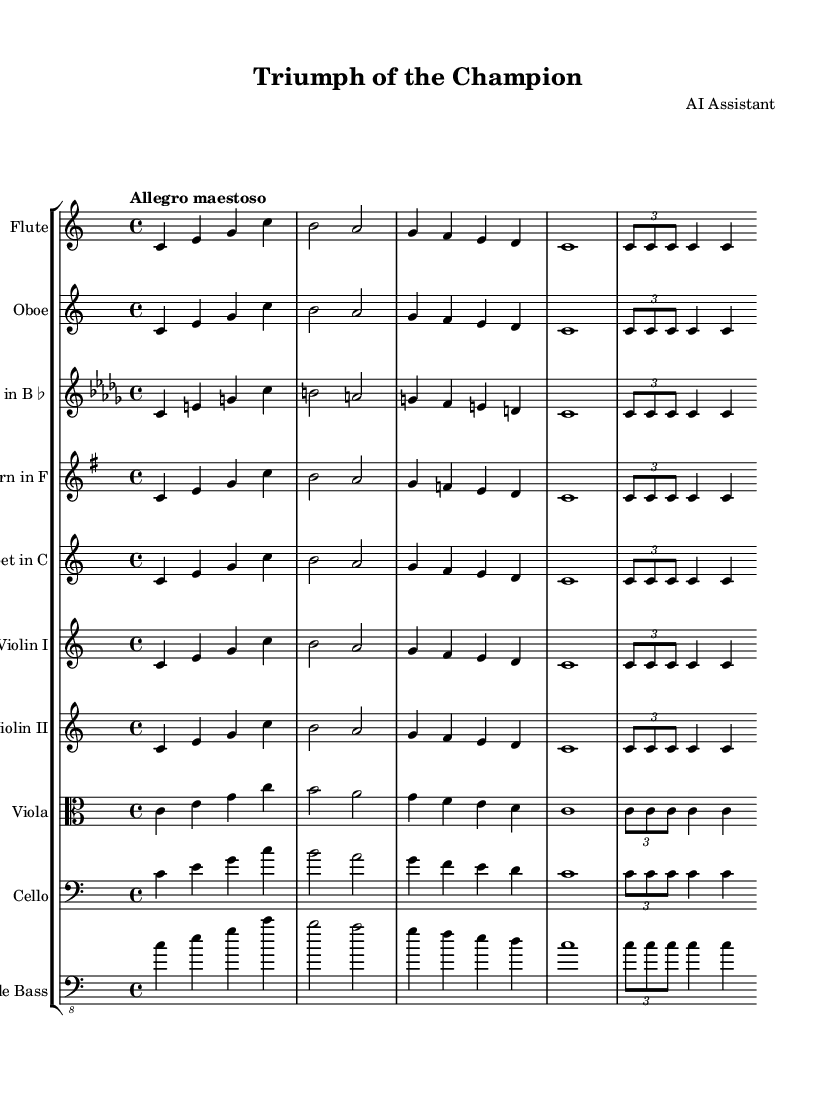What is the key signature of this music? The key signature is C major, which is indicated by the absence of any sharps or flats at the beginning of the staff.
Answer: C major What is the time signature of this piece? The time signature, indicated at the beginning of the staff, is 4/4, meaning there are four beats in a measure and the quarter note receives one beat.
Answer: 4/4 What is the tempo marking for this symphony? The tempo marking "Allegro maestoso" suggests a fast and majestic pace, which is shown at the top of the score.
Answer: Allegro maestoso How many measures are there in the main theme? By counting the segments of music for the main theme within the provided score, there are four measures depicted.
Answer: Four Which instruments play the main theme? The instruments listed in the score that play the main theme include Flute, Oboe, Clarinet in B♭, Horn in F, Trumpet in C, Violin I, Violin II, Viola, Cello, and Double Bass.
Answer: All instruments listed What technique is used in the rhythmic motif? The rhythmic motif features a triplet, demonstrated by the notation that groups three shorter notes into the duration of two notes, indicating a specific grouping of rhythms.
Answer: Triplet How does the instrumentation support the theme's character? The instrumentation combines woodwinds and strings, creating a rich and harmonious texture that enhances the majestic and triumphant character of the symphony theme.
Answer: Woodwinds and strings 